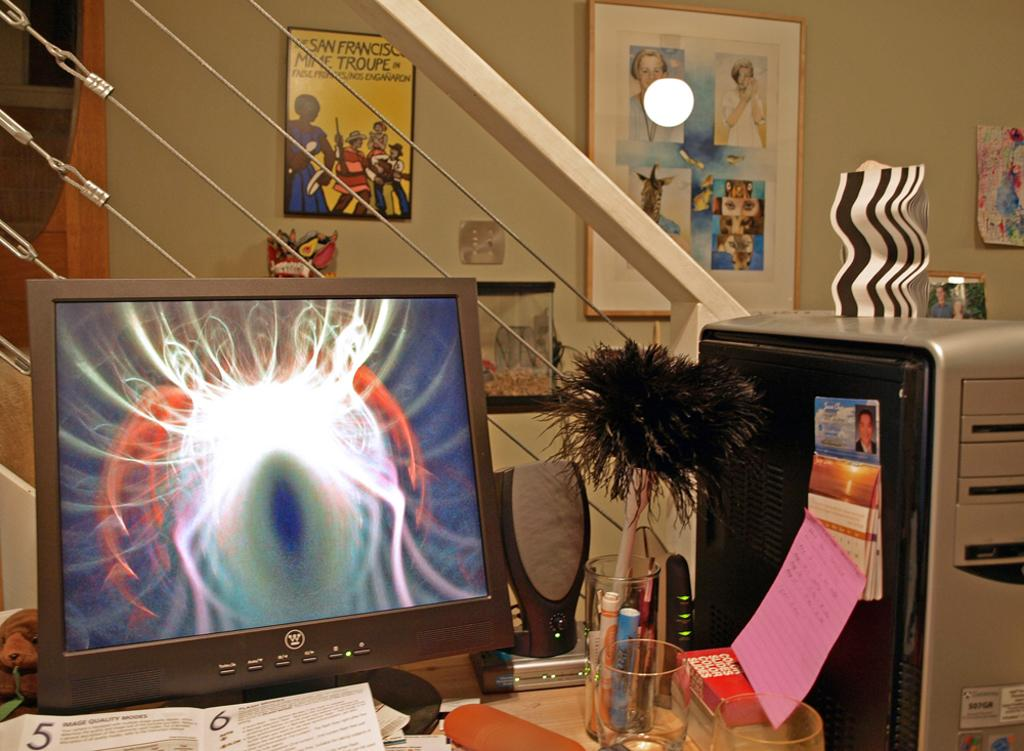<image>
Create a compact narrative representing the image presented. A computer monitor has a W logo on it below the screen. 